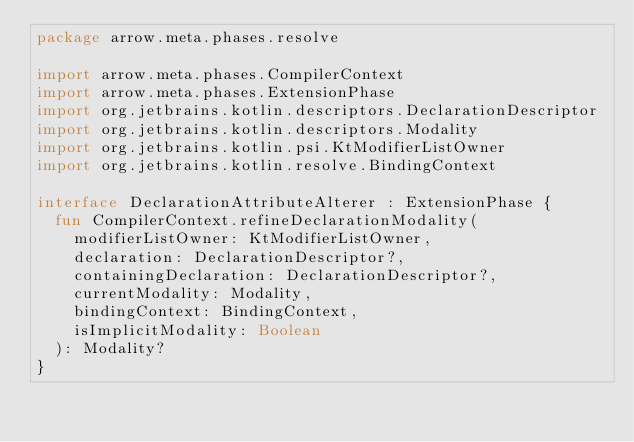Convert code to text. <code><loc_0><loc_0><loc_500><loc_500><_Kotlin_>package arrow.meta.phases.resolve

import arrow.meta.phases.CompilerContext
import arrow.meta.phases.ExtensionPhase
import org.jetbrains.kotlin.descriptors.DeclarationDescriptor
import org.jetbrains.kotlin.descriptors.Modality
import org.jetbrains.kotlin.psi.KtModifierListOwner
import org.jetbrains.kotlin.resolve.BindingContext

interface DeclarationAttributeAlterer : ExtensionPhase {
  fun CompilerContext.refineDeclarationModality(
    modifierListOwner: KtModifierListOwner,
    declaration: DeclarationDescriptor?,
    containingDeclaration: DeclarationDescriptor?,
    currentModality: Modality,
    bindingContext: BindingContext,
    isImplicitModality: Boolean
  ): Modality?
}</code> 